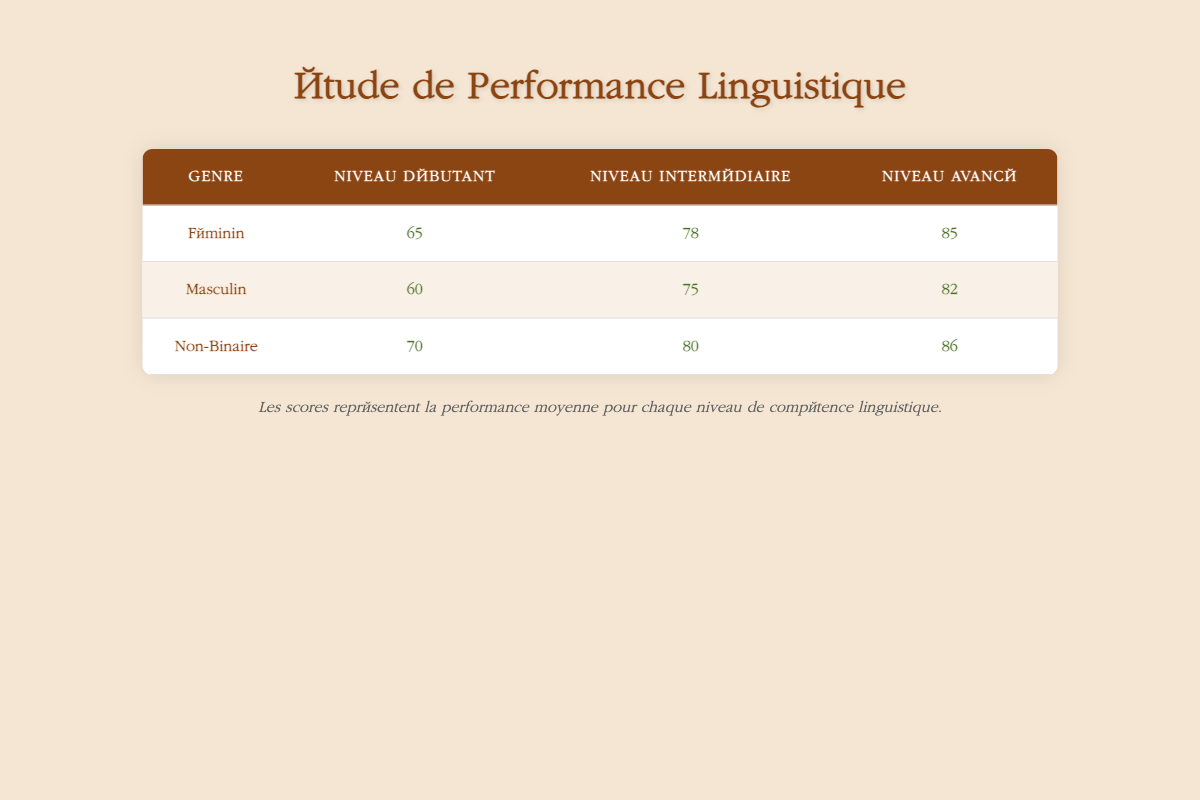What is the performance score for female students at the advanced level? According to the table, the performance score for female students at the advanced level is listed in the row for "Féminin" under "Niveau Avancé", where it states the score is 85.
Answer: 85 What is the lowest performance score among male students? The table displays the performance scores for male students: 60 for beginner, 75 for intermediate, and 82 for advanced. The lowest score is the one marked for beginner, which is 60.
Answer: 60 How many points higher is the advanced score of non-binary students compared to male students? The advanced score for non-binary students is 86, while for male students it is 82. Subtracting these gives 86 - 82 = 4, indicating non-binary students scored 4 points higher.
Answer: 4 Are female students performing better at the intermediate level compared to male students? At the intermediate level, the performance score for female students is 78, while for male students it is 75. Since 78 is greater than 75, female students are indeed performing better at this level.
Answer: Yes What is the average performance score for beginner-level students across all genders? To find the average, we take the scores of beginner-level students: Female (65), Male (60), Non-Binary (70). We sum these scores: 65 + 60 + 70 = 195. Since there are 3 scores, we divide 195 by 3, giving us 195 / 3 = 65.
Answer: 65 